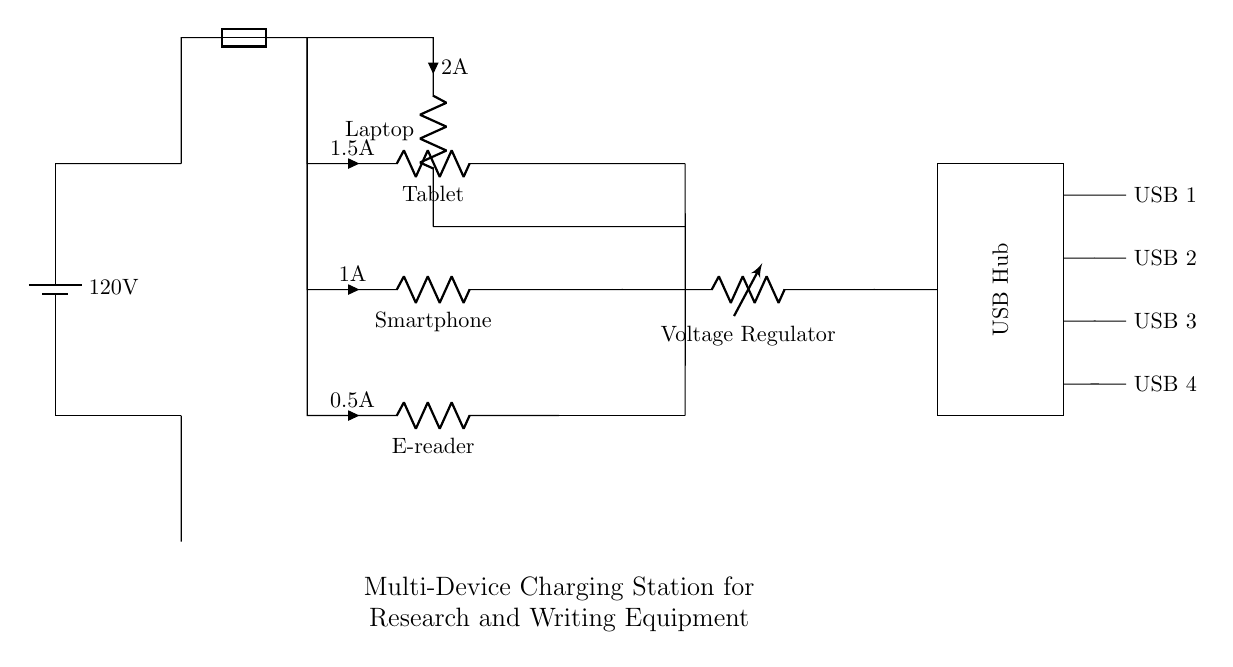What is the voltage of the power supply? The power supply is labeled as 120 volts, which indicates the potential difference provided to the circuit.
Answer: 120 volts What components are being powered by the charging station? The circuit diagram shows four components being powered: a laptop, a tablet, a smartphone, and an e-reader, each with their specified currents.
Answer: Laptop, tablet, smartphone, e-reader What is the current rating for the laptop charger? The charger for the laptop is indicated in the circuit as having a current of 2 amps, as noted next to its label.
Answer: 2 amps Which component regulates the voltage in the circuit? The voltage regulator is specifically mentioned in the circuit diagram, showing its function to maintain a specific voltage level for the connected devices.
Answer: Voltage regulator What is the total maximum current output of the charging station? The total current can be calculated by summing the individual currents for all devices: 2 amps (laptop) + 1.5 amps (tablet) + 1 amp (smartphone) + 0.5 amps (e-reader), totaling to 5 amps.
Answer: 5 amps What role does the fuse play in this circuit? The fuse is a safety device that protects the circuit from overcurrent conditions, ensuring that if too much current flows, it will break the circuit to prevent damage.
Answer: Safety device How many USB ports does the charging station provide? The diagram shows four USB outputs labeled as USB 1, USB 2, USB 3, and USB 4, indicating the number of ports available for charging.
Answer: Four USB ports 